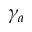Convert formula to latex. <formula><loc_0><loc_0><loc_500><loc_500>\gamma _ { a }</formula> 